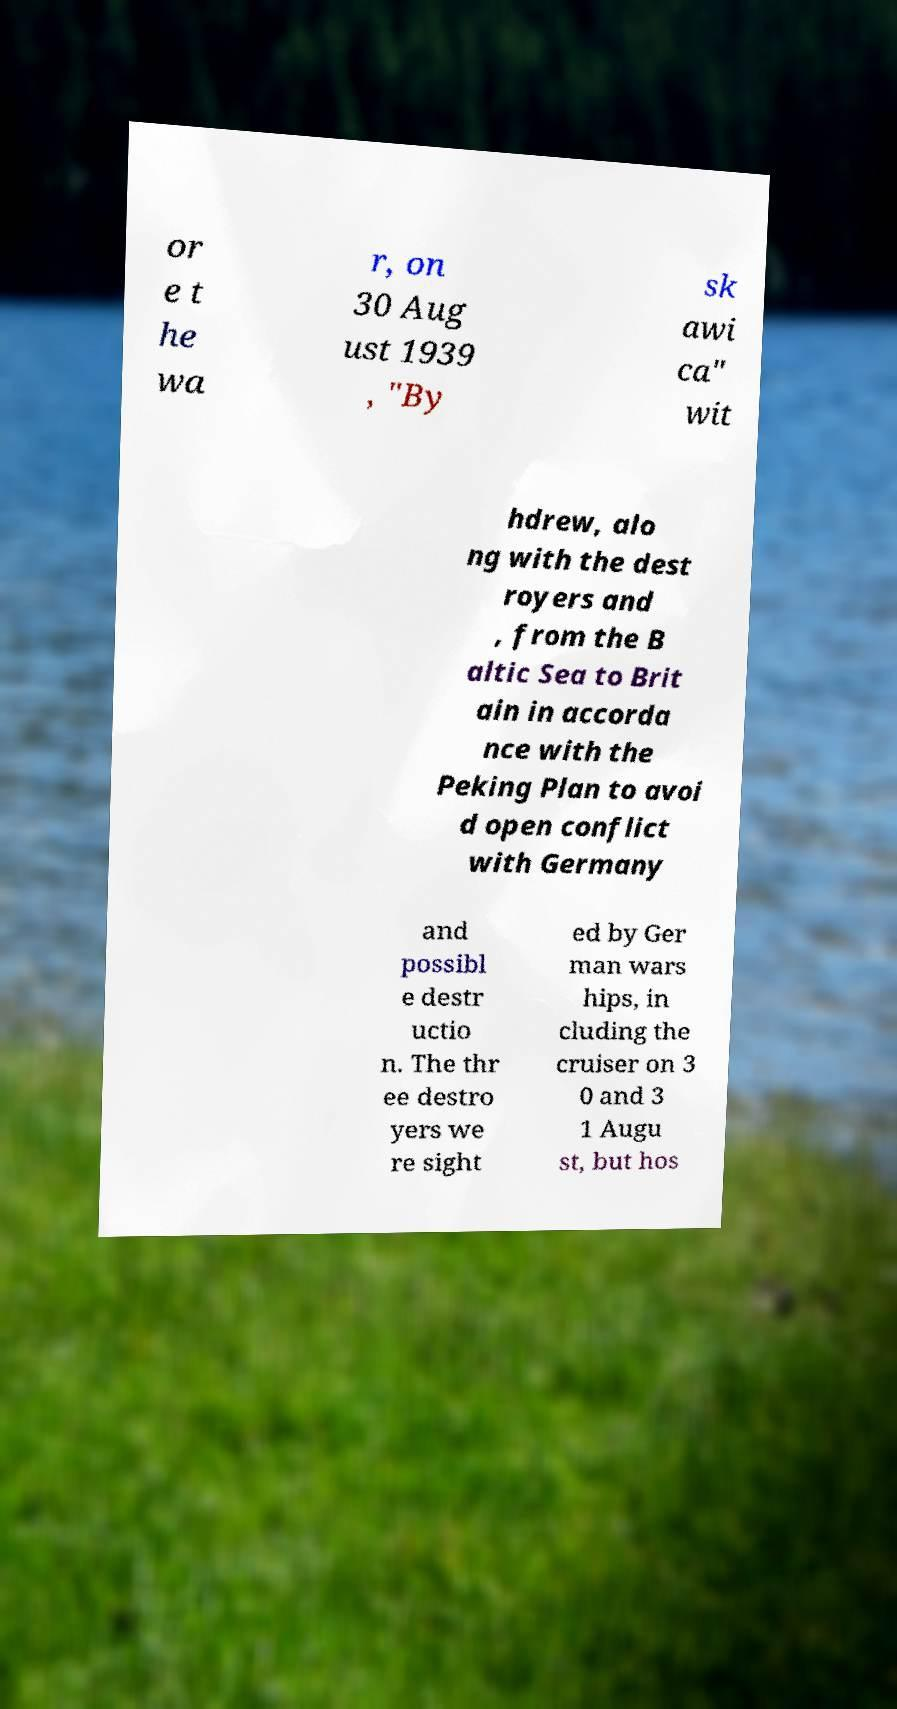Could you extract and type out the text from this image? or e t he wa r, on 30 Aug ust 1939 , "By sk awi ca" wit hdrew, alo ng with the dest royers and , from the B altic Sea to Brit ain in accorda nce with the Peking Plan to avoi d open conflict with Germany and possibl e destr uctio n. The thr ee destro yers we re sight ed by Ger man wars hips, in cluding the cruiser on 3 0 and 3 1 Augu st, but hos 